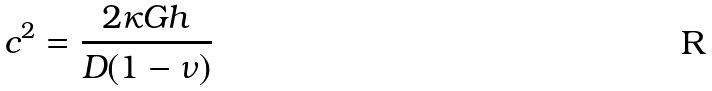Convert formula to latex. <formula><loc_0><loc_0><loc_500><loc_500>c ^ { 2 } = \frac { 2 \kappa G h } { D ( 1 - \nu ) }</formula> 